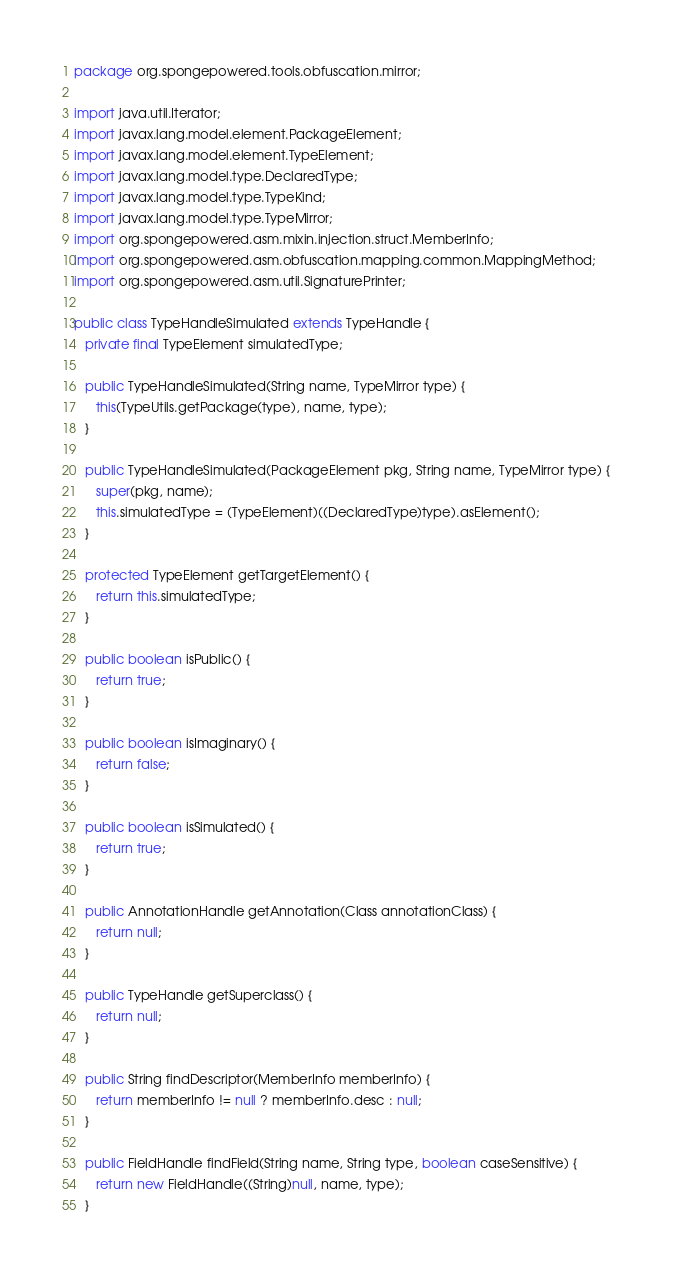Convert code to text. <code><loc_0><loc_0><loc_500><loc_500><_Java_>package org.spongepowered.tools.obfuscation.mirror;

import java.util.Iterator;
import javax.lang.model.element.PackageElement;
import javax.lang.model.element.TypeElement;
import javax.lang.model.type.DeclaredType;
import javax.lang.model.type.TypeKind;
import javax.lang.model.type.TypeMirror;
import org.spongepowered.asm.mixin.injection.struct.MemberInfo;
import org.spongepowered.asm.obfuscation.mapping.common.MappingMethod;
import org.spongepowered.asm.util.SignaturePrinter;

public class TypeHandleSimulated extends TypeHandle {
   private final TypeElement simulatedType;

   public TypeHandleSimulated(String name, TypeMirror type) {
      this(TypeUtils.getPackage(type), name, type);
   }

   public TypeHandleSimulated(PackageElement pkg, String name, TypeMirror type) {
      super(pkg, name);
      this.simulatedType = (TypeElement)((DeclaredType)type).asElement();
   }

   protected TypeElement getTargetElement() {
      return this.simulatedType;
   }

   public boolean isPublic() {
      return true;
   }

   public boolean isImaginary() {
      return false;
   }

   public boolean isSimulated() {
      return true;
   }

   public AnnotationHandle getAnnotation(Class annotationClass) {
      return null;
   }

   public TypeHandle getSuperclass() {
      return null;
   }

   public String findDescriptor(MemberInfo memberInfo) {
      return memberInfo != null ? memberInfo.desc : null;
   }

   public FieldHandle findField(String name, String type, boolean caseSensitive) {
      return new FieldHandle((String)null, name, type);
   }
</code> 